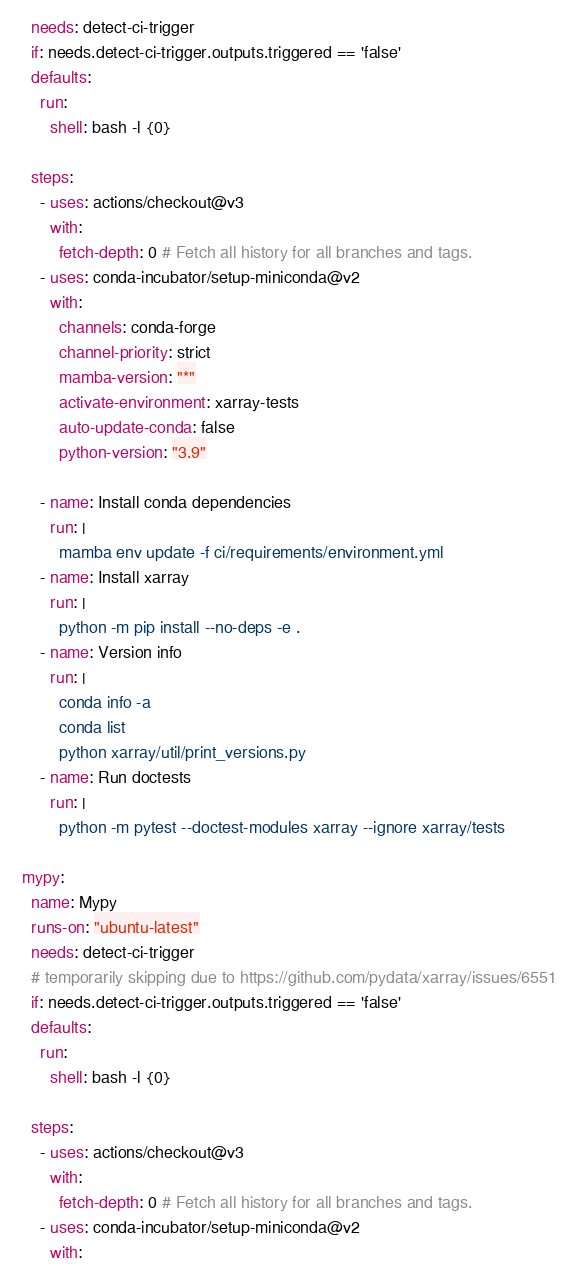<code> <loc_0><loc_0><loc_500><loc_500><_YAML_>    needs: detect-ci-trigger
    if: needs.detect-ci-trigger.outputs.triggered == 'false'
    defaults:
      run:
        shell: bash -l {0}

    steps:
      - uses: actions/checkout@v3
        with:
          fetch-depth: 0 # Fetch all history for all branches and tags.
      - uses: conda-incubator/setup-miniconda@v2
        with:
          channels: conda-forge
          channel-priority: strict
          mamba-version: "*"
          activate-environment: xarray-tests
          auto-update-conda: false
          python-version: "3.9"

      - name: Install conda dependencies
        run: |
          mamba env update -f ci/requirements/environment.yml
      - name: Install xarray
        run: |
          python -m pip install --no-deps -e .
      - name: Version info
        run: |
          conda info -a
          conda list
          python xarray/util/print_versions.py
      - name: Run doctests
        run: |
          python -m pytest --doctest-modules xarray --ignore xarray/tests

  mypy:
    name: Mypy
    runs-on: "ubuntu-latest"
    needs: detect-ci-trigger
    # temporarily skipping due to https://github.com/pydata/xarray/issues/6551
    if: needs.detect-ci-trigger.outputs.triggered == 'false'
    defaults:
      run:
        shell: bash -l {0}

    steps:
      - uses: actions/checkout@v3
        with:
          fetch-depth: 0 # Fetch all history for all branches and tags.
      - uses: conda-incubator/setup-miniconda@v2
        with:</code> 